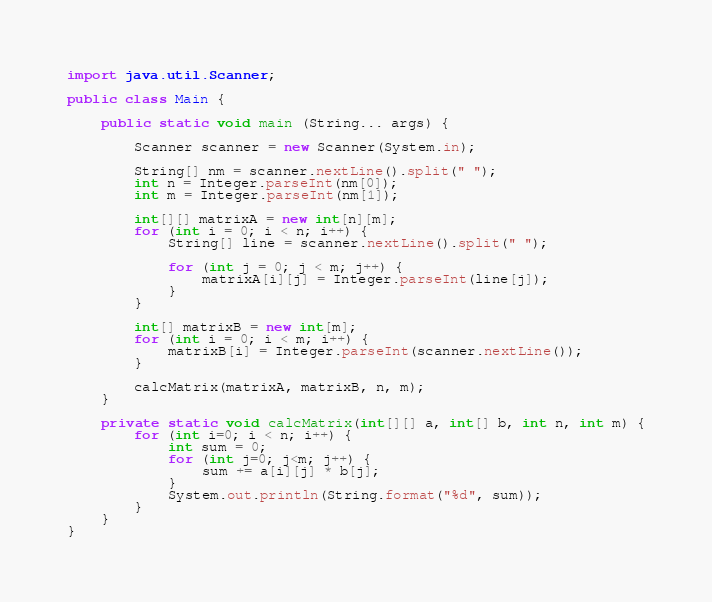Convert code to text. <code><loc_0><loc_0><loc_500><loc_500><_Java_>import java.util.Scanner;

public class Main {
    
    public static void main (String... args) {
        
        Scanner scanner = new Scanner(System.in);
        
        String[] nm = scanner.nextLine().split(" ");
        int n = Integer.parseInt(nm[0]);
        int m = Integer.parseInt(nm[1]);
        
        int[][] matrixA = new int[n][m];
        for (int i = 0; i < n; i++) {
            String[] line = scanner.nextLine().split(" ");
            
            for (int j = 0; j < m; j++) {
                matrixA[i][j] = Integer.parseInt(line[j]);
            }
        }
        
        int[] matrixB = new int[m];
        for (int i = 0; i < m; i++) {
            matrixB[i] = Integer.parseInt(scanner.nextLine());
        }
        
        calcMatrix(matrixA, matrixB, n, m);
    }
    
    private static void calcMatrix(int[][] a, int[] b, int n, int m) {
        for (int i=0; i < n; i++) {
            int sum = 0;
            for (int j=0; j<m; j++) {
                sum += a[i][j] * b[j];
            }
            System.out.println(String.format("%d", sum));
        }
    }
}
</code> 